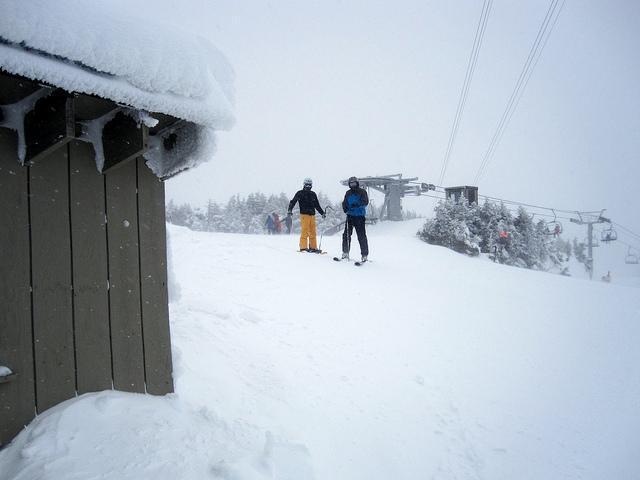How many knives to you see?
Give a very brief answer. 0. 